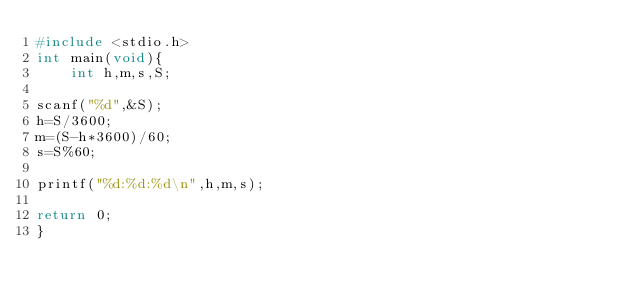Convert code to text. <code><loc_0><loc_0><loc_500><loc_500><_C_>#include <stdio.h>
int main(void){
    int h,m,s,S;
   
scanf("%d",&S);
h=S/3600;
m=(S-h*3600)/60;
s=S%60;

printf("%d:%d:%d\n",h,m,s);

return 0;
}</code> 